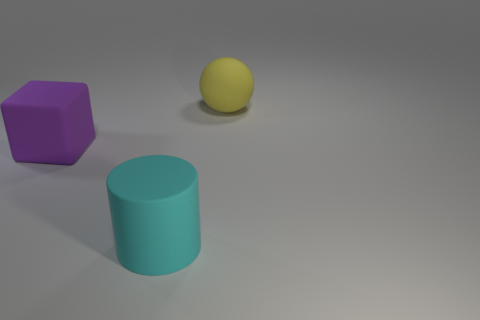Is there anything else that is the same shape as the large cyan rubber object?
Make the answer very short. No. Does the thing behind the purple matte cube have the same color as the object that is in front of the big purple thing?
Give a very brief answer. No. Is the number of purple blocks behind the large purple matte thing greater than the number of big yellow matte objects?
Your answer should be very brief. No. What number of other objects are the same size as the cylinder?
Your answer should be very brief. 2. What number of matte things are behind the purple object and in front of the yellow matte ball?
Your answer should be compact. 0. Are the big thing that is behind the large purple thing and the big purple thing made of the same material?
Ensure brevity in your answer.  Yes. The object right of the large rubber object in front of the large thing that is left of the large cyan cylinder is what shape?
Give a very brief answer. Sphere. Are there an equal number of large purple blocks that are behind the large purple block and big matte cylinders behind the big yellow matte sphere?
Offer a very short reply. Yes. What color is the sphere that is the same size as the cyan matte object?
Offer a terse response. Yellow. How many small objects are cyan objects or balls?
Offer a very short reply. 0. 